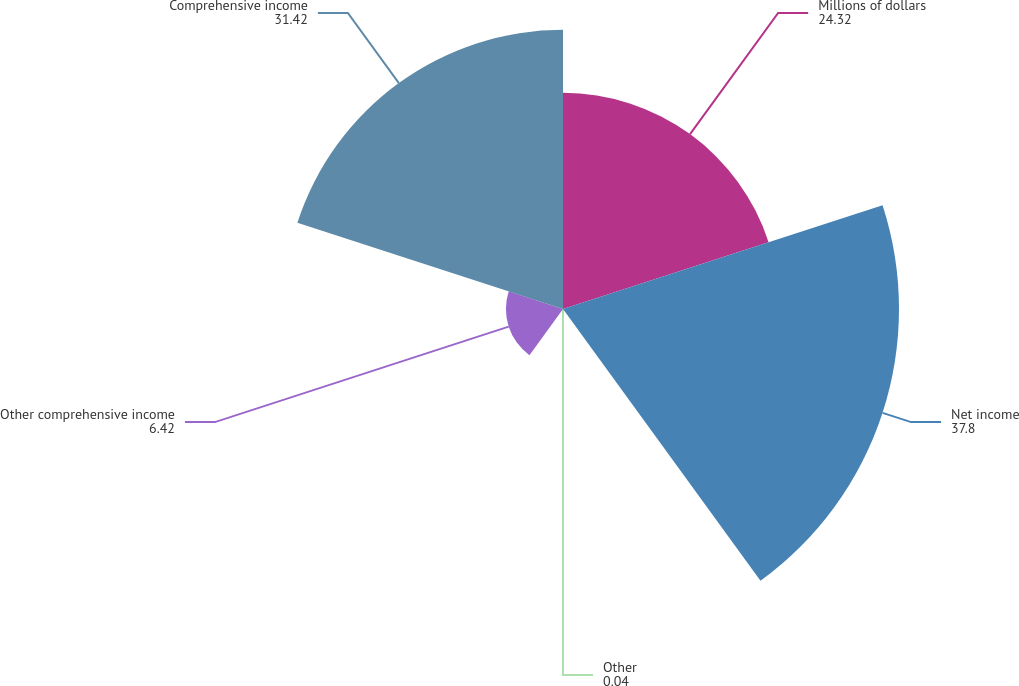<chart> <loc_0><loc_0><loc_500><loc_500><pie_chart><fcel>Millions of dollars<fcel>Net income<fcel>Other<fcel>Other comprehensive income<fcel>Comprehensive income<nl><fcel>24.32%<fcel>37.8%<fcel>0.04%<fcel>6.42%<fcel>31.42%<nl></chart> 